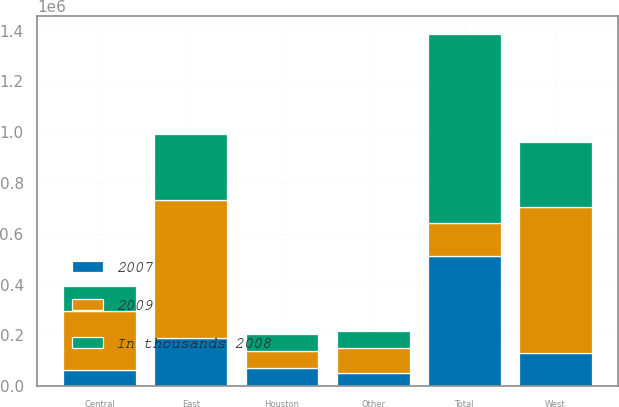<chart> <loc_0><loc_0><loc_500><loc_500><stacked_bar_chart><ecel><fcel>East<fcel>Central<fcel>West<fcel>Houston<fcel>Other<fcel>Total<nl><fcel>2007<fcel>190600<fcel>65448<fcel>129476<fcel>72480<fcel>54030<fcel>512034<nl><fcel>In thousands 2008<fcel>260118<fcel>97136<fcel>253732<fcel>67408<fcel>68124<fcel>746518<nl><fcel>2009<fcel>543727<fcel>231603<fcel>577734<fcel>67637<fcel>95133<fcel>129476<nl></chart> 